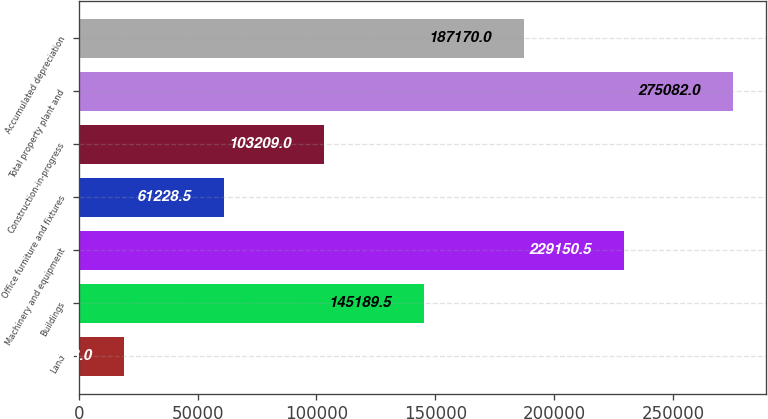Convert chart to OTSL. <chart><loc_0><loc_0><loc_500><loc_500><bar_chart><fcel>Land<fcel>Buildings<fcel>Machinery and equipment<fcel>Office furniture and fixtures<fcel>Construction-in-progress<fcel>Total property plant and<fcel>Accumulated depreciation<nl><fcel>19248<fcel>145190<fcel>229150<fcel>61228.5<fcel>103209<fcel>275082<fcel>187170<nl></chart> 